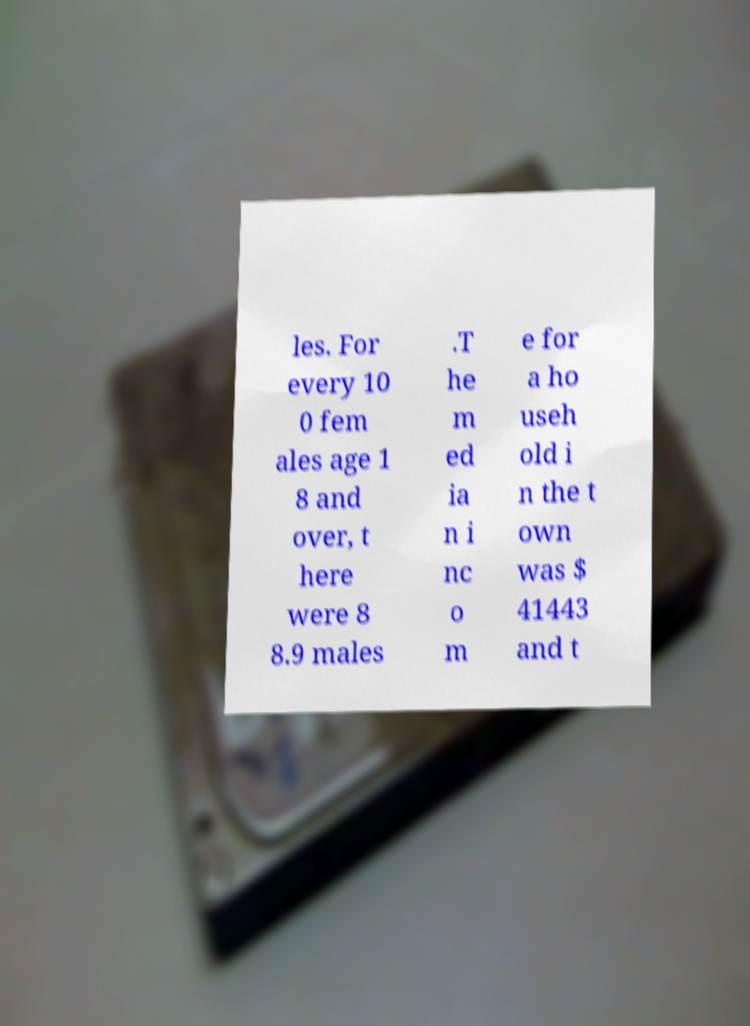I need the written content from this picture converted into text. Can you do that? les. For every 10 0 fem ales age 1 8 and over, t here were 8 8.9 males .T he m ed ia n i nc o m e for a ho useh old i n the t own was $ 41443 and t 